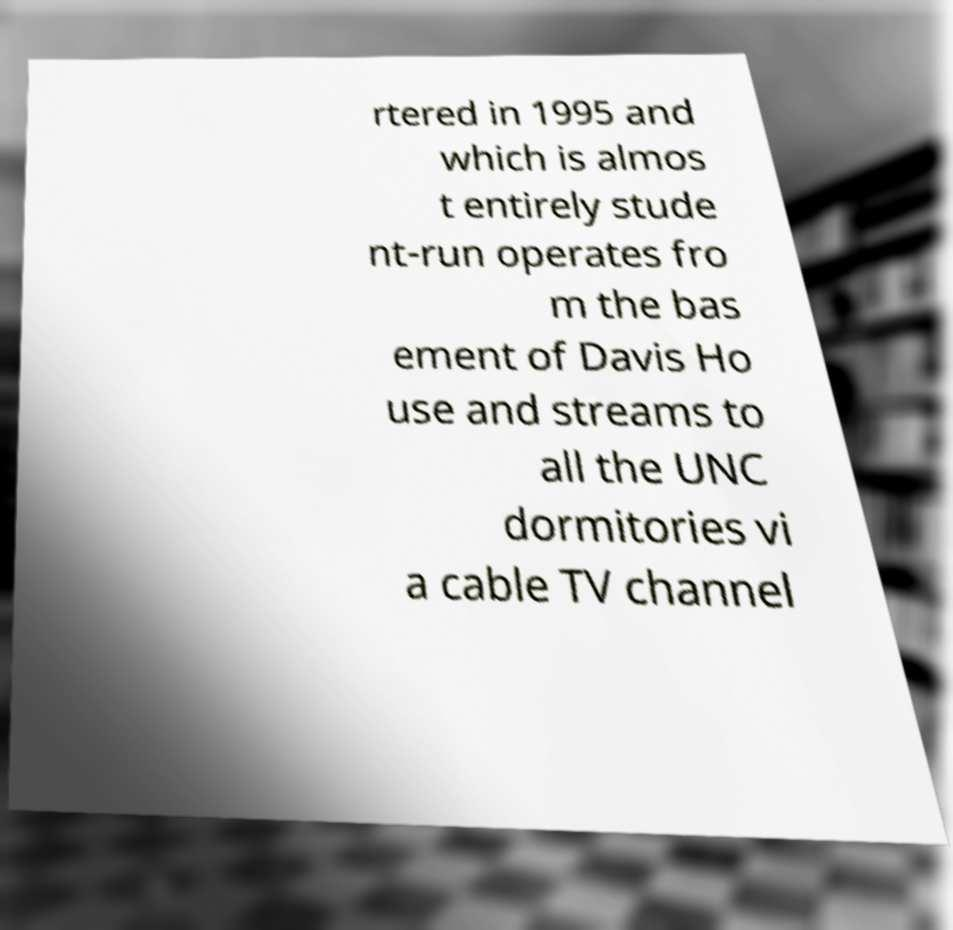For documentation purposes, I need the text within this image transcribed. Could you provide that? rtered in 1995 and which is almos t entirely stude nt-run operates fro m the bas ement of Davis Ho use and streams to all the UNC dormitories vi a cable TV channel 